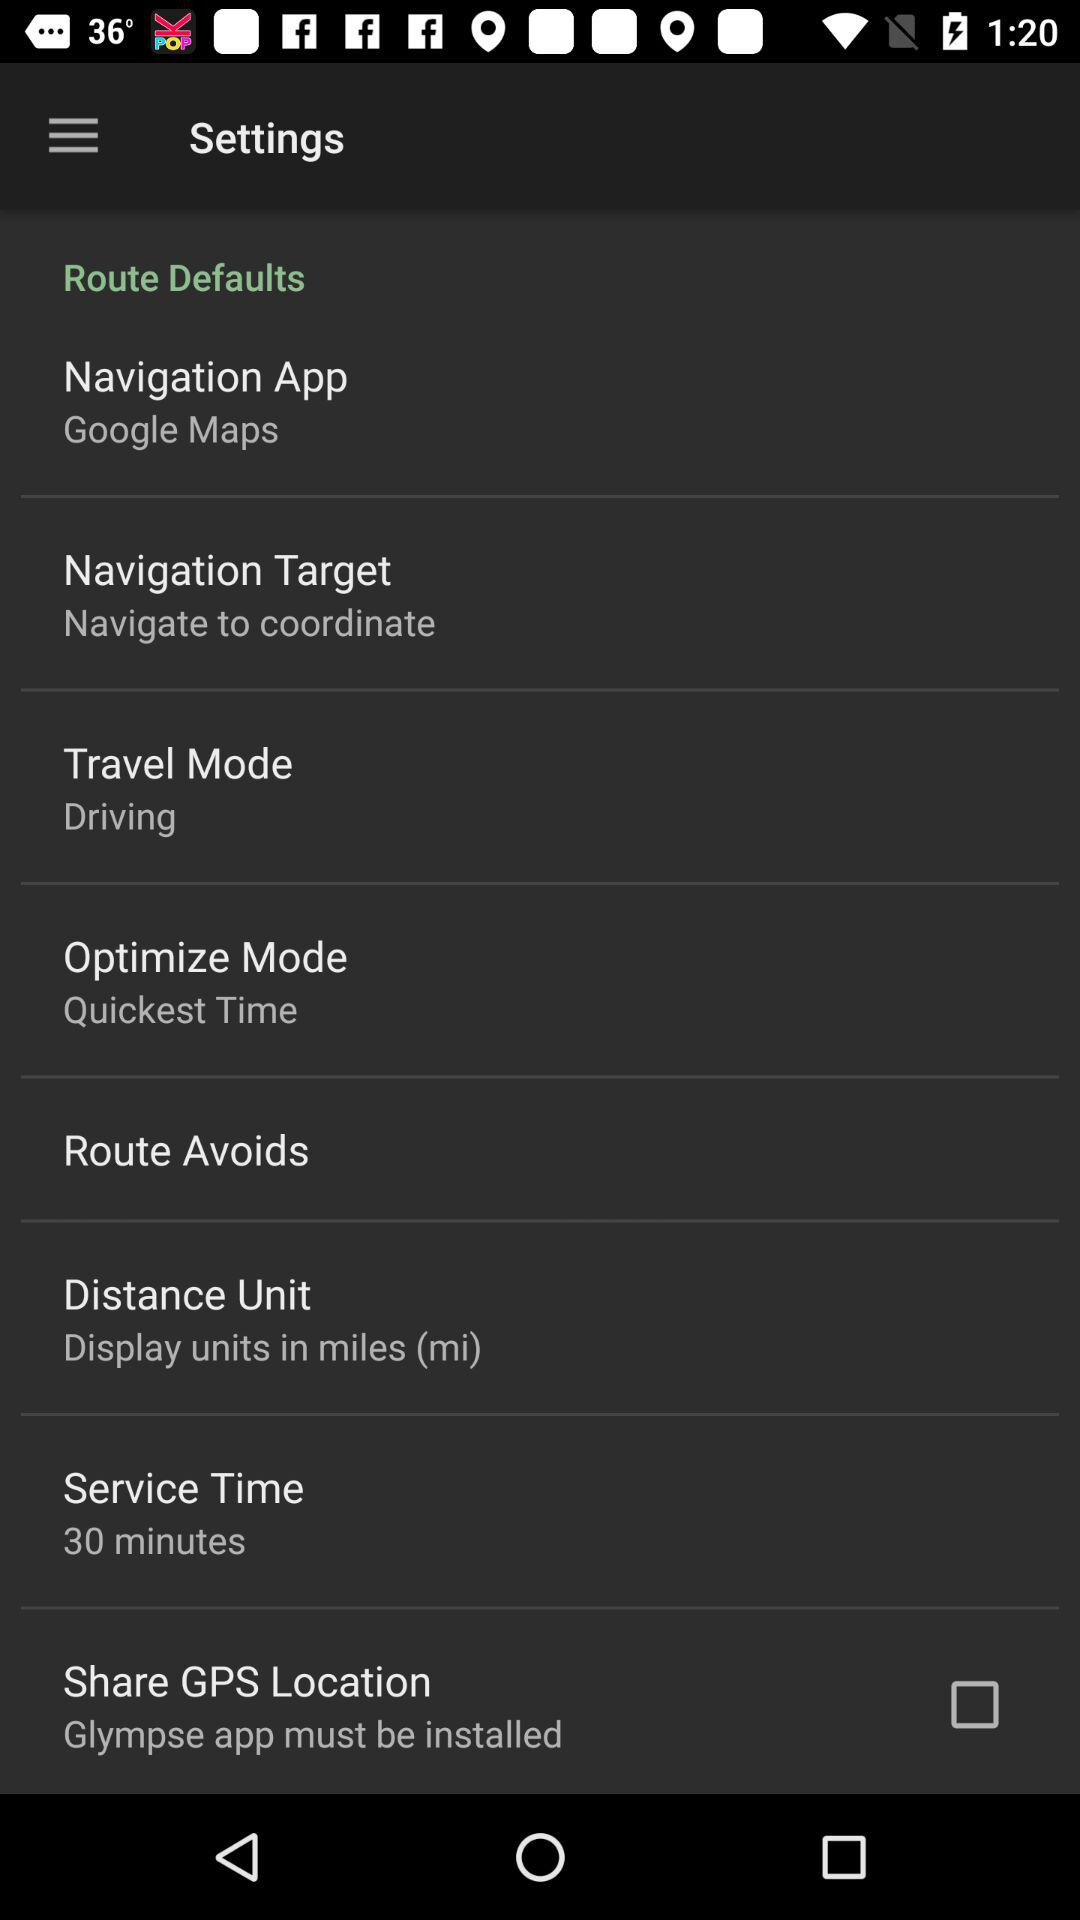What travel mode is displayed? The displayed travel mode is "Driving". 